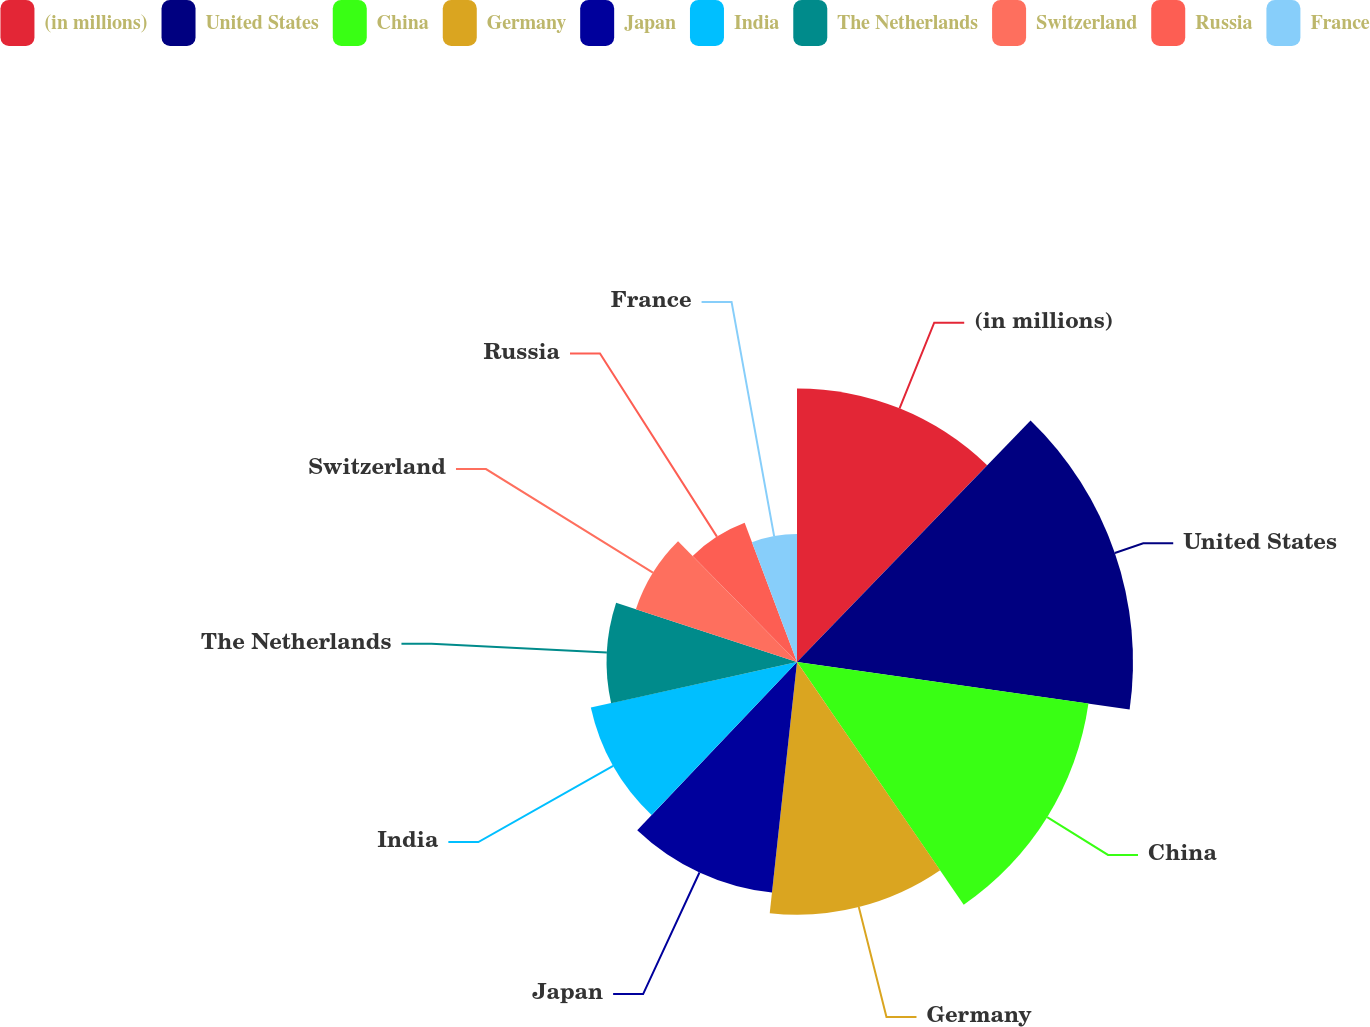<chart> <loc_0><loc_0><loc_500><loc_500><pie_chart><fcel>(in millions)<fcel>United States<fcel>China<fcel>Germany<fcel>Japan<fcel>India<fcel>The Netherlands<fcel>Switzerland<fcel>Russia<fcel>France<nl><fcel>12.23%<fcel>15.02%<fcel>13.16%<fcel>11.3%<fcel>10.37%<fcel>9.44%<fcel>8.51%<fcel>7.58%<fcel>6.65%<fcel>5.72%<nl></chart> 